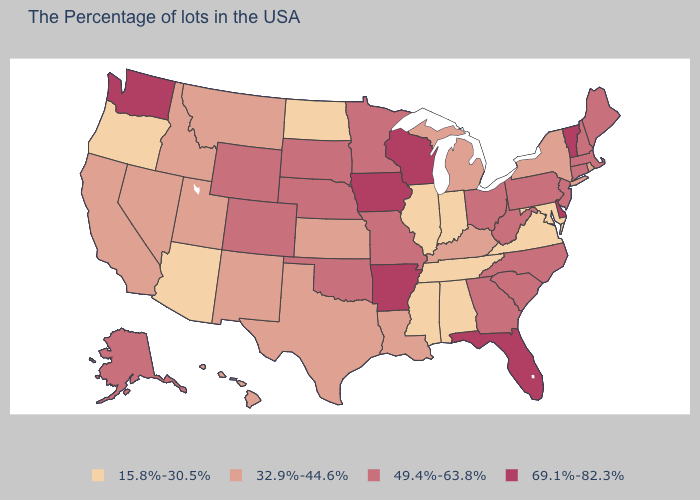Does the first symbol in the legend represent the smallest category?
Quick response, please. Yes. Does Vermont have the highest value in the USA?
Keep it brief. Yes. What is the value of North Carolina?
Give a very brief answer. 49.4%-63.8%. What is the highest value in the Northeast ?
Quick response, please. 69.1%-82.3%. What is the value of Kansas?
Write a very short answer. 32.9%-44.6%. Does South Dakota have the lowest value in the USA?
Concise answer only. No. Among the states that border Mississippi , which have the lowest value?
Give a very brief answer. Alabama, Tennessee. Does the first symbol in the legend represent the smallest category?
Answer briefly. Yes. Is the legend a continuous bar?
Short answer required. No. Which states have the lowest value in the MidWest?
Give a very brief answer. Indiana, Illinois, North Dakota. Does Massachusetts have the same value as Delaware?
Be succinct. No. Does Arizona have a higher value than South Carolina?
Give a very brief answer. No. Name the states that have a value in the range 69.1%-82.3%?
Keep it brief. Vermont, Delaware, Florida, Wisconsin, Arkansas, Iowa, Washington. Name the states that have a value in the range 49.4%-63.8%?
Write a very short answer. Maine, Massachusetts, New Hampshire, Connecticut, New Jersey, Pennsylvania, North Carolina, South Carolina, West Virginia, Ohio, Georgia, Missouri, Minnesota, Nebraska, Oklahoma, South Dakota, Wyoming, Colorado, Alaska. How many symbols are there in the legend?
Answer briefly. 4. 